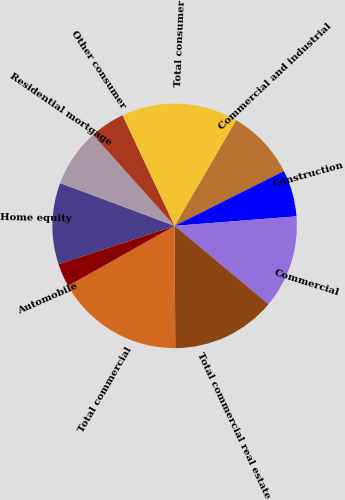Convert chart to OTSL. <chart><loc_0><loc_0><loc_500><loc_500><pie_chart><fcel>Commercial and industrial<fcel>Construction<fcel>Commercial<fcel>Total commercial real estate<fcel>Total commercial<fcel>Automobile<fcel>Home equity<fcel>Residential mortgage<fcel>Other consumer<fcel>Total consumer<nl><fcel>9.23%<fcel>6.15%<fcel>12.31%<fcel>13.85%<fcel>16.92%<fcel>3.08%<fcel>10.77%<fcel>7.69%<fcel>4.62%<fcel>15.38%<nl></chart> 